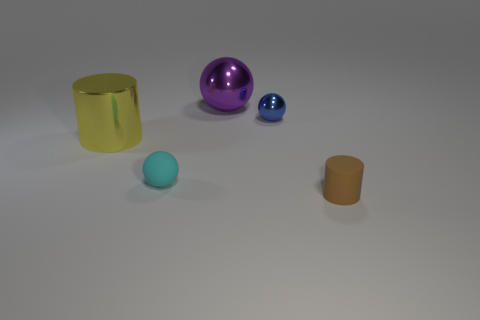Add 1 tiny metallic balls. How many objects exist? 6 Subtract all metallic balls. How many balls are left? 1 Subtract all gray spheres. Subtract all cyan cubes. How many spheres are left? 3 Subtract all balls. How many objects are left? 2 Add 4 large cylinders. How many large cylinders exist? 5 Subtract 0 red balls. How many objects are left? 5 Subtract all blue things. Subtract all red shiny cylinders. How many objects are left? 4 Add 2 cyan balls. How many cyan balls are left? 3 